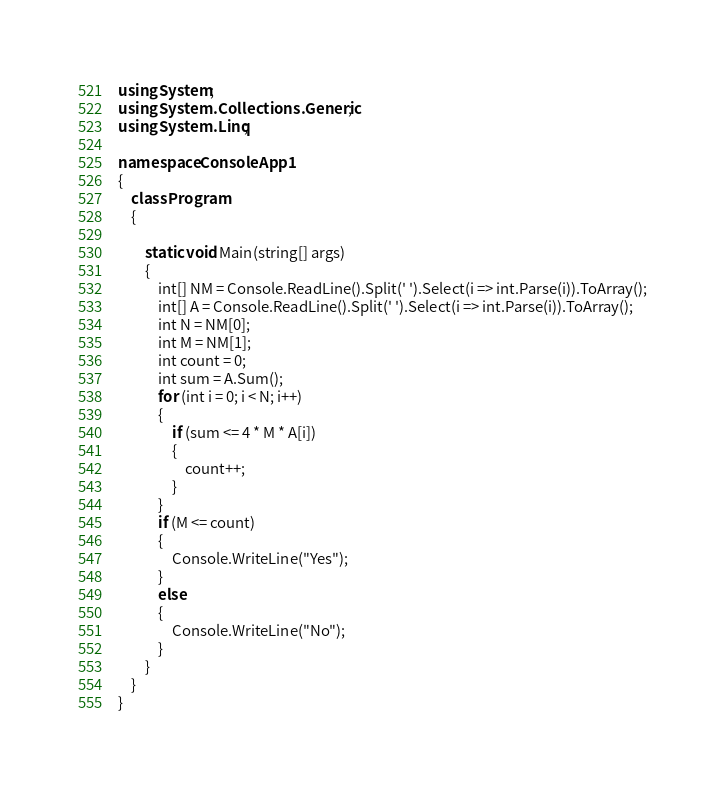Convert code to text. <code><loc_0><loc_0><loc_500><loc_500><_C#_>using System;
using System.Collections.Generic;
using System.Linq;

namespace ConsoleApp1
{
    class Program
    {
  
        static void Main(string[] args)
        {
            int[] NM = Console.ReadLine().Split(' ').Select(i => int.Parse(i)).ToArray();
            int[] A = Console.ReadLine().Split(' ').Select(i => int.Parse(i)).ToArray();
            int N = NM[0];
            int M = NM[1];
            int count = 0;
            int sum = A.Sum();
            for (int i = 0; i < N; i++)
            {
                if (sum <= 4 * M * A[i])
                {
                    count++;
                }
            }
            if (M <= count)
            {
                Console.WriteLine("Yes");
            }
            else
            {
                Console.WriteLine("No");
            }
        }
    }
}</code> 